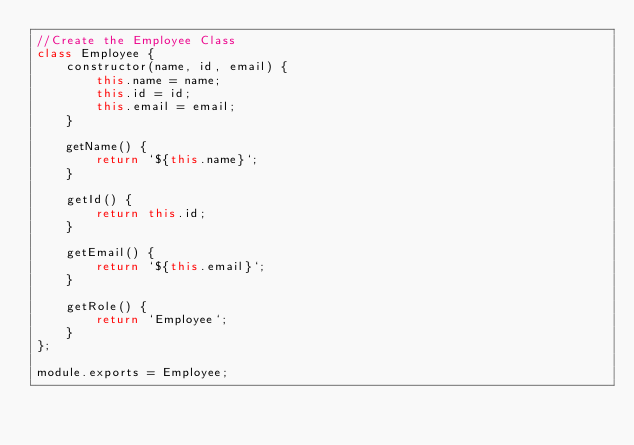<code> <loc_0><loc_0><loc_500><loc_500><_JavaScript_>//Create the Employee Class
class Employee {
    constructor(name, id, email) {
        this.name = name;
        this.id = id;
        this.email = email;
    }

    getName() {
        return `${this.name}`;
    }

    getId() {
        return this.id;
    }

    getEmail() {
        return `${this.email}`;
    }
    
    getRole() {
        return `Employee`;
    }
};

module.exports = Employee;</code> 